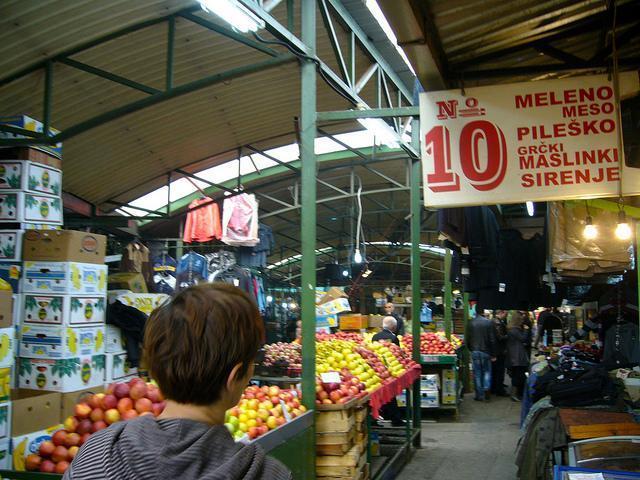How many apples are there?
Give a very brief answer. 2. 